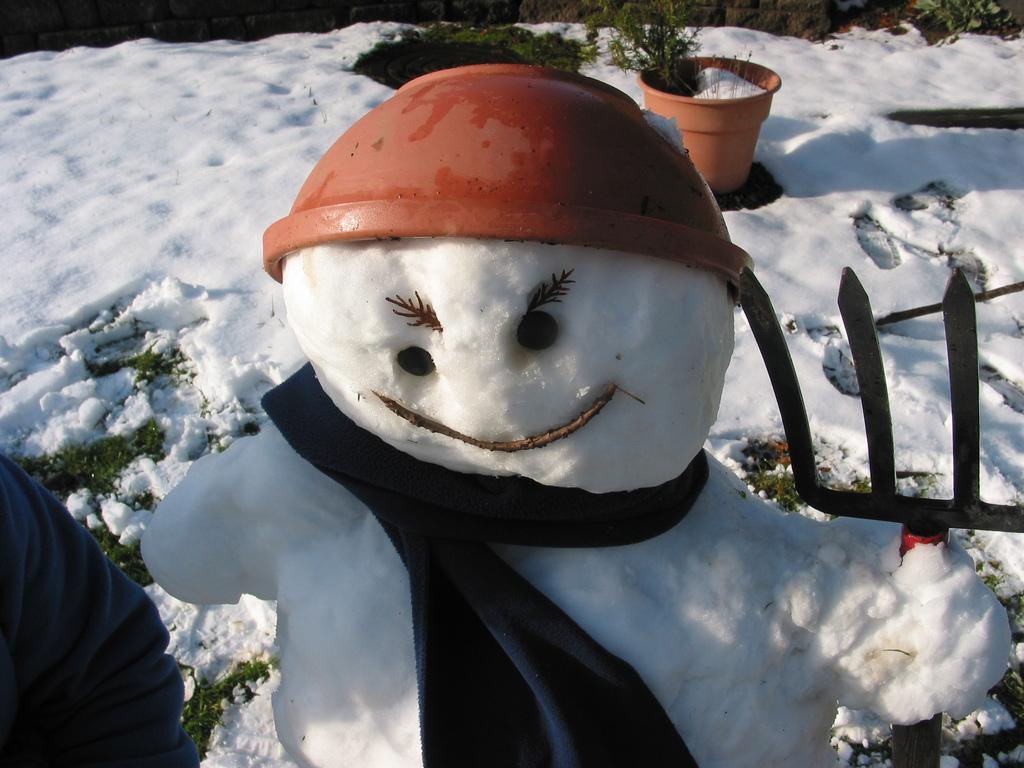How would you summarize this image in a sentence or two? In this picture there is a snow man with pot and a jerking and he is holding a tool. Towards the bottom left there is a person. In the background there is snow, flower pot, plants etc. 